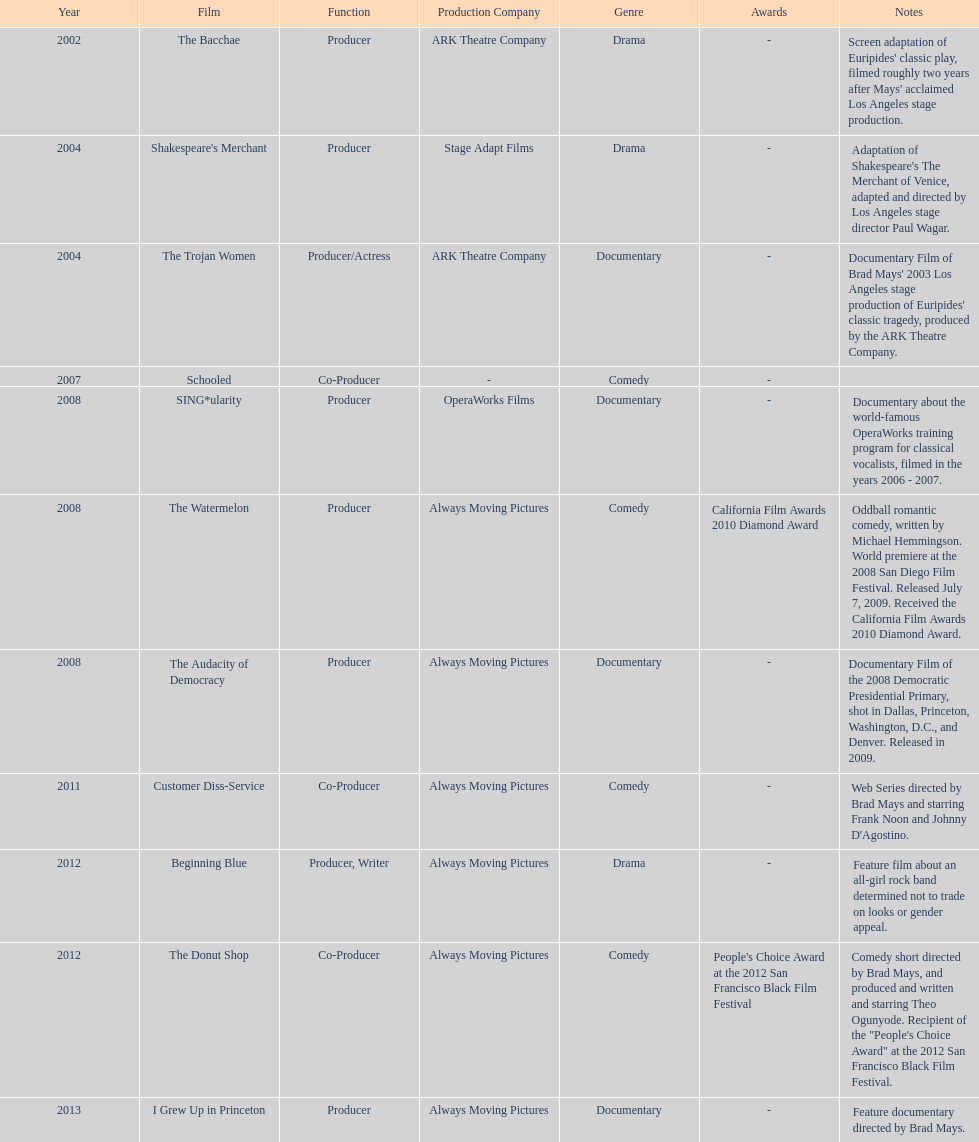Which film was before the audacity of democracy? The Watermelon. 